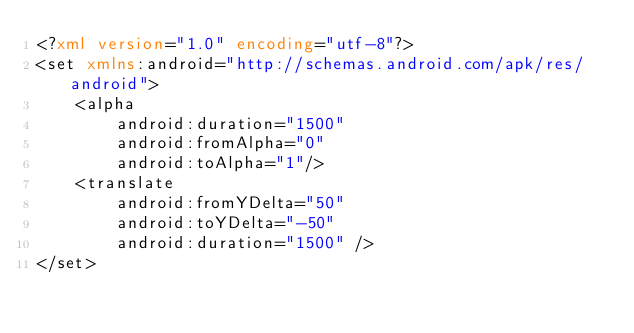Convert code to text. <code><loc_0><loc_0><loc_500><loc_500><_XML_><?xml version="1.0" encoding="utf-8"?>
<set xmlns:android="http://schemas.android.com/apk/res/android">
    <alpha
        android:duration="1500"
        android:fromAlpha="0"
        android:toAlpha="1"/>
    <translate
        android:fromYDelta="50"
        android:toYDelta="-50"
        android:duration="1500" />
</set></code> 